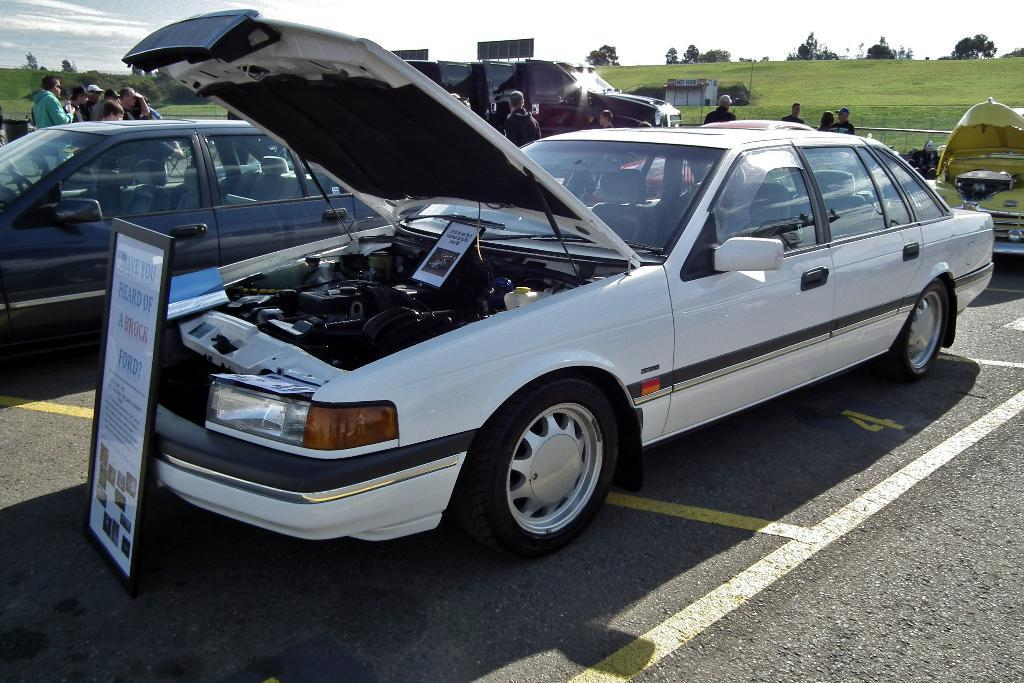What can be seen on the road in the image? There are cars parked on the road in the image. What are the people behind the parked cars doing? The people standing behind the parked cars are not doing anything specific in the image. What type of surface is the ground covered with? The ground is covered with grass. What type of vegetation is present at the back of the scene? There are many trees at the back of the scene. What type of lettuce is being used as a food source in the image? There is no lettuce or food source present in the image. How does the car burst into flames in the image? The cars in the image are parked and not in flames, so there is no bursting into flames. 